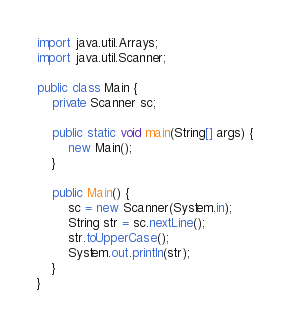<code> <loc_0><loc_0><loc_500><loc_500><_Java_>import java.util.Arrays;
import java.util.Scanner;

public class Main {
	private Scanner sc;
	
	public static void main(String[] args) {
		new Main();
	}
	
	public Main() {
		sc = new Scanner(System.in);
		String str = sc.nextLine();
		str.toUpperCase();
		System.out.println(str);
	}
}</code> 